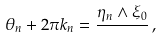<formula> <loc_0><loc_0><loc_500><loc_500>\theta _ { n } + 2 \pi k _ { n } = \frac { \eta _ { n } \wedge \xi _ { 0 } } { } \, ,</formula> 